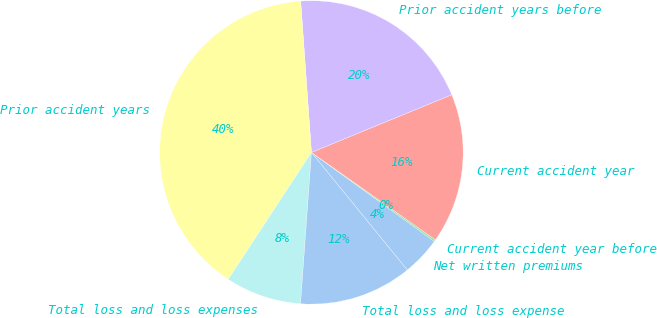Convert chart. <chart><loc_0><loc_0><loc_500><loc_500><pie_chart><fcel>Net written premiums<fcel>Current accident year before<fcel>Current accident year<fcel>Prior accident years before<fcel>Prior accident years<fcel>Total loss and loss expenses<fcel>Total loss and loss expense<nl><fcel>4.14%<fcel>0.2%<fcel>15.98%<fcel>19.92%<fcel>39.64%<fcel>8.09%<fcel>12.03%<nl></chart> 